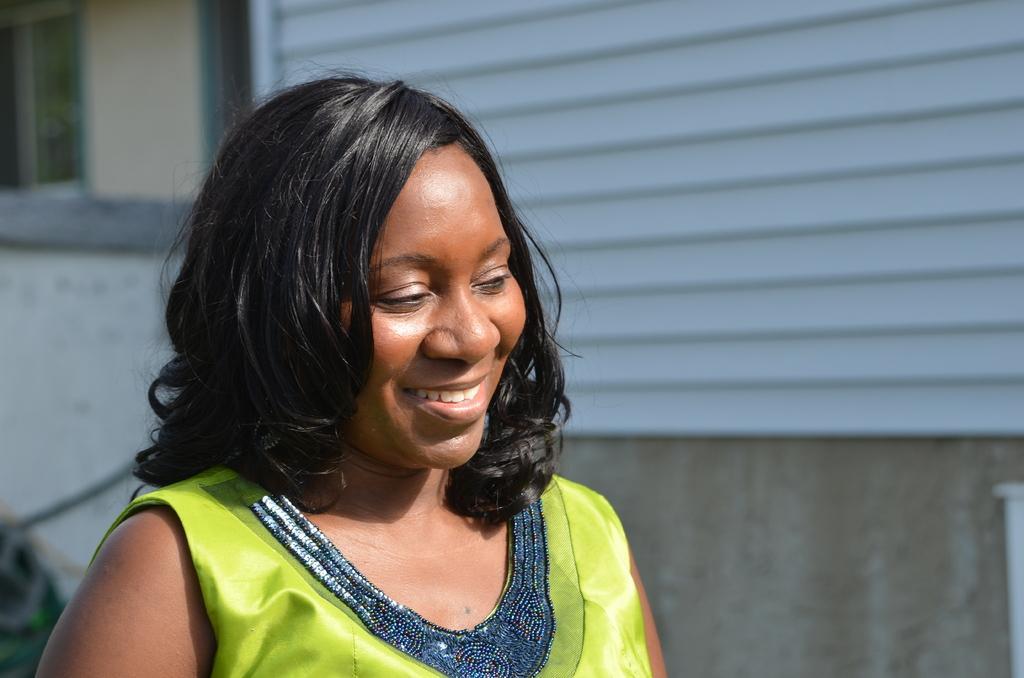How would you summarize this image in a sentence or two? In this picture there is a woman who is wearing green dress. In the back I can see the building. In the top left corner I can see the window. 